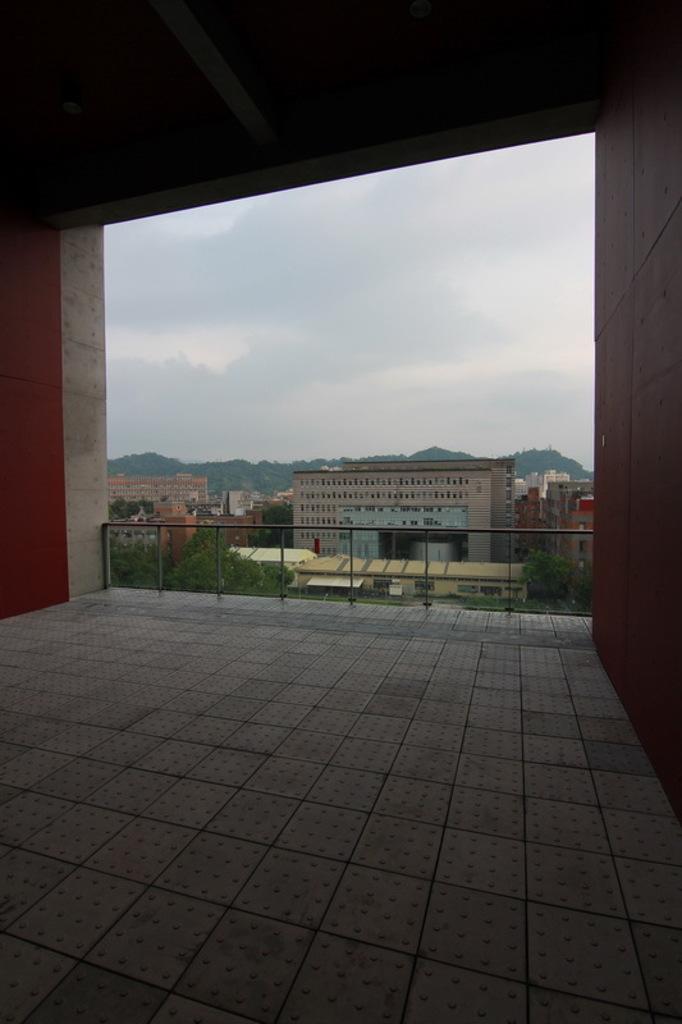Can you describe this image briefly? This is an inside view of a shed. On the right and left side of the image I can see the walls. In the background there are some buildings and trees. On the top I can see the sky. 